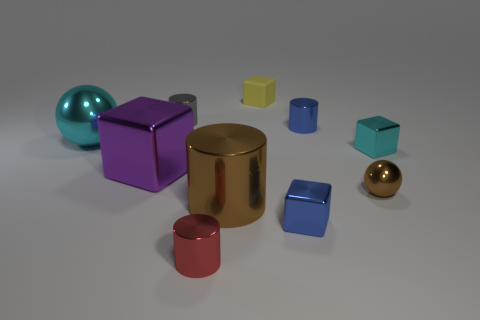Subtract all big purple shiny cubes. How many cubes are left? 3 Subtract 2 cubes. How many cubes are left? 2 Subtract all purple cubes. How many cubes are left? 3 Add 2 purple shiny objects. How many purple shiny objects are left? 3 Add 1 small gray shiny things. How many small gray shiny things exist? 2 Subtract 1 yellow cubes. How many objects are left? 9 Subtract all cylinders. How many objects are left? 6 Subtract all red cylinders. Subtract all cyan balls. How many cylinders are left? 3 Subtract all brown objects. Subtract all large red metallic balls. How many objects are left? 8 